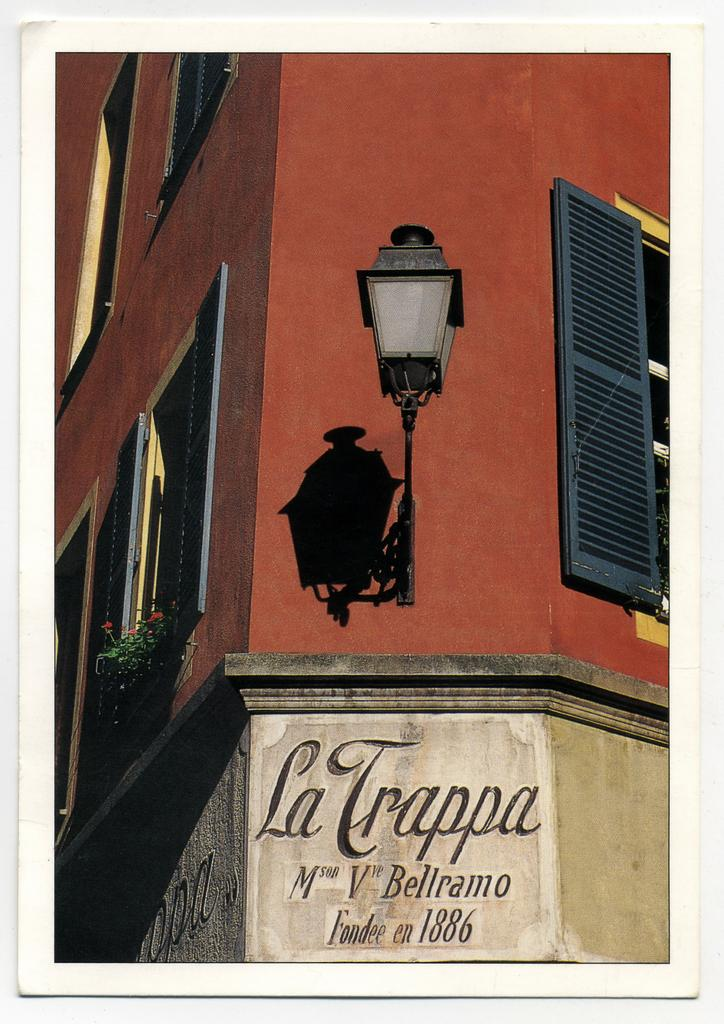What is the main structure in the center of the image? There is a building with windows in the center of the image. Can you describe any other features of the building? There is a light visible in the image, which may be part of the building. Is there any text present in the image? Yes, there is some text on the wall at the bottom of the image. How many jellyfish can be seen swimming near the building in the image? There are no jellyfish present in the image; it features a building with windows and a light. What type of heart is depicted on the wall in the image? There is no heart depicted on the wall in the image; it features text instead. 